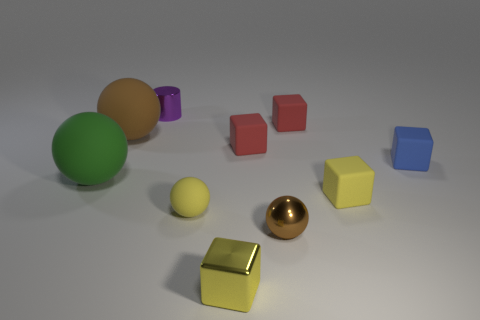Is there any other thing that is made of the same material as the small yellow ball?
Keep it short and to the point. Yes. How many tiny purple cubes are there?
Keep it short and to the point. 0. Is the shiny ball the same color as the metallic cylinder?
Provide a short and direct response. No. There is a small cube that is both behind the small yellow matte sphere and in front of the green sphere; what is its color?
Provide a succinct answer. Yellow. There is a green matte thing; are there any small metallic balls behind it?
Your answer should be very brief. No. How many small matte cubes are in front of the brown object behind the small blue rubber object?
Ensure brevity in your answer.  3. The yellow object that is made of the same material as the small yellow ball is what size?
Provide a short and direct response. Small. The green rubber sphere has what size?
Provide a succinct answer. Large. Do the tiny brown ball and the blue block have the same material?
Provide a succinct answer. No. How many blocks are either tiny purple objects or yellow shiny things?
Provide a short and direct response. 1. 